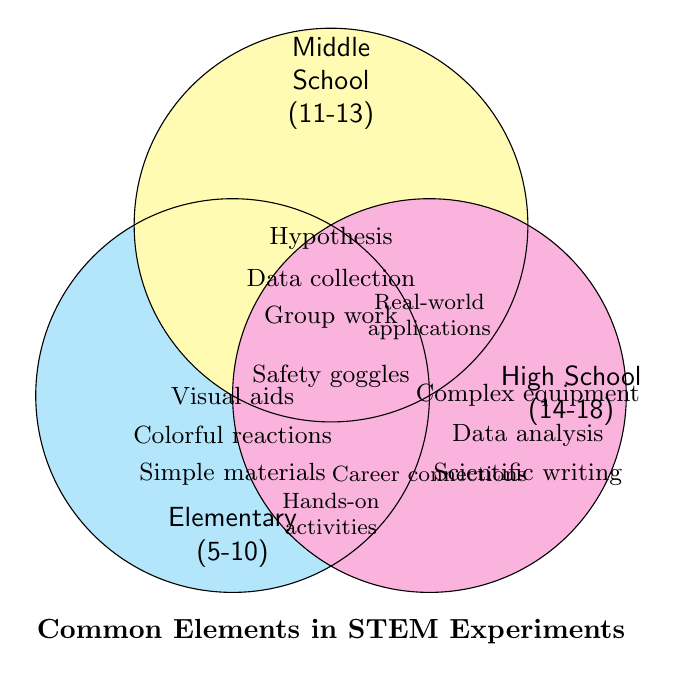What is the title of the Venn diagram? The title is typically at the top or bottom of the diagram. It gives a short description of the content.
Answer: Common Elements in STEM Experiments Which age groups share the 'Safety goggles' element? The intersection (overlapping area) of different segments in a Venn diagram can show common elements. Here, 'Safety goggles' is shared by all three age groups as it is in the overlapping area common to all three circles.
Answer: Elementary, Middle School, High School What are the unique elements for the Elementary age group? Unique elements are found within the non-overlapping area of that group’s circle. For Elementary, these are 'Simple materials', 'Colorful reactions', 'Hands-on activities', and 'Visual aids'.
Answer: Simple materials, Colorful reactions, Hands-on activities, Visual aids What elements are common between Middle School and High School, but not shared with Elementary? Look at the overlapping area between Middle School and High School circles that doesn't overlap with the Elementary circle. These elements are 'Real-world applications' and 'Career connections'.
Answer: Real-world applications, Career connections Is 'Data collection' a common element for any two age groups? Check where 'Data collection' is placed in the diagram. It is within the Middle School circle only.
Answer: No Which age group emphasizes ‘Complex equipment’? Elements specific to a particular age group are outside the overlapping areas in their specific circle. 'Complex equipment' is found within the High School circle.
Answer: High School Do any elements listed in the Venn diagram connect all three age groups? Elements in the intersection of all three circles apply to all mentioned age groups. 'Safety goggles' is shown in the overlap of all three segments.
Answer: Yes, Safety goggles How many elements are unique to Middle School? Counting elements in the non-overlapping area of the Middle School circle: 'Hypothesis formation', 'Data collection', 'Group work'.
Answer: 3 What elements are shared between Elementary and Middle School but not High School? These elements lie in the overlap between Elementary and Middle School circles but outside the High School circle. No such region or elements are displayed.
Answer: None What is the focus on career connections associated with? Career connections are given as an element within the High School group circle.
Answer: High School 